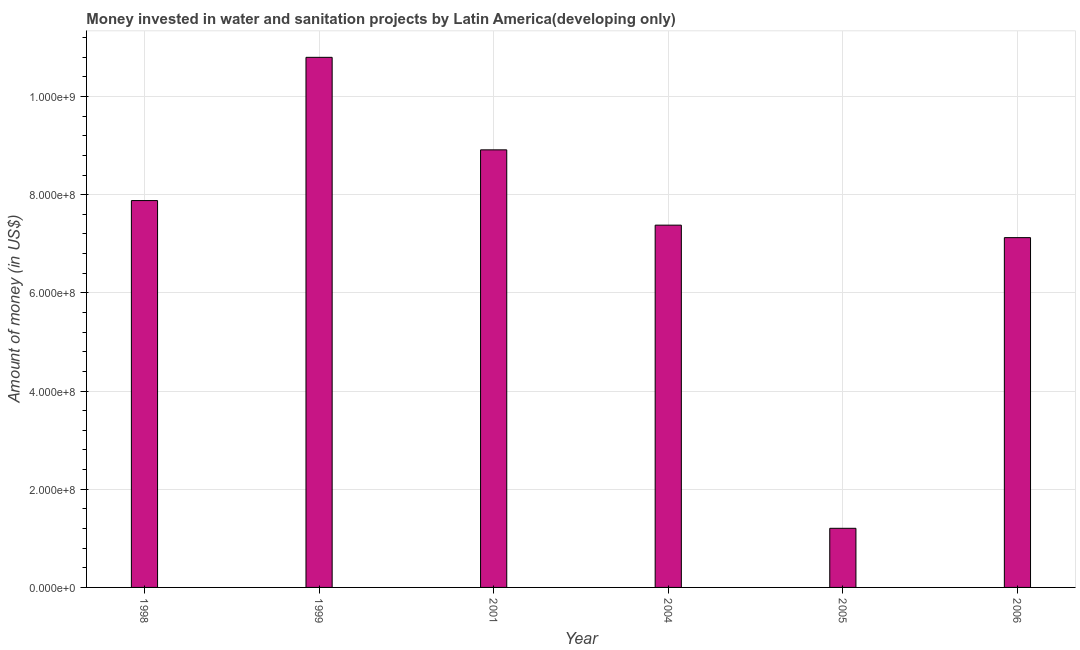Does the graph contain any zero values?
Your answer should be compact. No. What is the title of the graph?
Provide a succinct answer. Money invested in water and sanitation projects by Latin America(developing only). What is the label or title of the X-axis?
Your answer should be very brief. Year. What is the label or title of the Y-axis?
Give a very brief answer. Amount of money (in US$). What is the investment in 1998?
Make the answer very short. 7.88e+08. Across all years, what is the maximum investment?
Your answer should be very brief. 1.08e+09. Across all years, what is the minimum investment?
Provide a short and direct response. 1.20e+08. What is the sum of the investment?
Offer a terse response. 4.33e+09. What is the difference between the investment in 2004 and 2005?
Your response must be concise. 6.18e+08. What is the average investment per year?
Provide a succinct answer. 7.22e+08. What is the median investment?
Offer a very short reply. 7.63e+08. What is the ratio of the investment in 1999 to that in 2005?
Your response must be concise. 8.97. Is the investment in 1999 less than that in 2001?
Provide a short and direct response. No. Is the difference between the investment in 1998 and 1999 greater than the difference between any two years?
Offer a terse response. No. What is the difference between the highest and the second highest investment?
Make the answer very short. 1.88e+08. What is the difference between the highest and the lowest investment?
Your answer should be compact. 9.59e+08. In how many years, is the investment greater than the average investment taken over all years?
Your answer should be very brief. 4. How many bars are there?
Your answer should be very brief. 6. How many years are there in the graph?
Make the answer very short. 6. What is the Amount of money (in US$) in 1998?
Give a very brief answer. 7.88e+08. What is the Amount of money (in US$) of 1999?
Your answer should be compact. 1.08e+09. What is the Amount of money (in US$) of 2001?
Your response must be concise. 8.91e+08. What is the Amount of money (in US$) in 2004?
Provide a short and direct response. 7.38e+08. What is the Amount of money (in US$) in 2005?
Give a very brief answer. 1.20e+08. What is the Amount of money (in US$) of 2006?
Provide a short and direct response. 7.13e+08. What is the difference between the Amount of money (in US$) in 1998 and 1999?
Give a very brief answer. -2.92e+08. What is the difference between the Amount of money (in US$) in 1998 and 2001?
Your response must be concise. -1.03e+08. What is the difference between the Amount of money (in US$) in 1998 and 2004?
Your response must be concise. 5.01e+07. What is the difference between the Amount of money (in US$) in 1998 and 2005?
Offer a very short reply. 6.68e+08. What is the difference between the Amount of money (in US$) in 1998 and 2006?
Keep it short and to the point. 7.55e+07. What is the difference between the Amount of money (in US$) in 1999 and 2001?
Offer a very short reply. 1.88e+08. What is the difference between the Amount of money (in US$) in 1999 and 2004?
Ensure brevity in your answer.  3.42e+08. What is the difference between the Amount of money (in US$) in 1999 and 2005?
Provide a succinct answer. 9.59e+08. What is the difference between the Amount of money (in US$) in 1999 and 2006?
Offer a very short reply. 3.67e+08. What is the difference between the Amount of money (in US$) in 2001 and 2004?
Keep it short and to the point. 1.53e+08. What is the difference between the Amount of money (in US$) in 2001 and 2005?
Provide a short and direct response. 7.71e+08. What is the difference between the Amount of money (in US$) in 2001 and 2006?
Ensure brevity in your answer.  1.79e+08. What is the difference between the Amount of money (in US$) in 2004 and 2005?
Provide a succinct answer. 6.18e+08. What is the difference between the Amount of money (in US$) in 2004 and 2006?
Ensure brevity in your answer.  2.54e+07. What is the difference between the Amount of money (in US$) in 2005 and 2006?
Make the answer very short. -5.92e+08. What is the ratio of the Amount of money (in US$) in 1998 to that in 1999?
Keep it short and to the point. 0.73. What is the ratio of the Amount of money (in US$) in 1998 to that in 2001?
Your response must be concise. 0.88. What is the ratio of the Amount of money (in US$) in 1998 to that in 2004?
Keep it short and to the point. 1.07. What is the ratio of the Amount of money (in US$) in 1998 to that in 2005?
Your answer should be compact. 6.54. What is the ratio of the Amount of money (in US$) in 1998 to that in 2006?
Provide a succinct answer. 1.11. What is the ratio of the Amount of money (in US$) in 1999 to that in 2001?
Give a very brief answer. 1.21. What is the ratio of the Amount of money (in US$) in 1999 to that in 2004?
Offer a very short reply. 1.46. What is the ratio of the Amount of money (in US$) in 1999 to that in 2005?
Ensure brevity in your answer.  8.97. What is the ratio of the Amount of money (in US$) in 1999 to that in 2006?
Offer a terse response. 1.51. What is the ratio of the Amount of money (in US$) in 2001 to that in 2004?
Your response must be concise. 1.21. What is the ratio of the Amount of money (in US$) in 2001 to that in 2005?
Offer a terse response. 7.4. What is the ratio of the Amount of money (in US$) in 2001 to that in 2006?
Your answer should be very brief. 1.25. What is the ratio of the Amount of money (in US$) in 2004 to that in 2005?
Your response must be concise. 6.13. What is the ratio of the Amount of money (in US$) in 2004 to that in 2006?
Provide a short and direct response. 1.04. What is the ratio of the Amount of money (in US$) in 2005 to that in 2006?
Give a very brief answer. 0.17. 